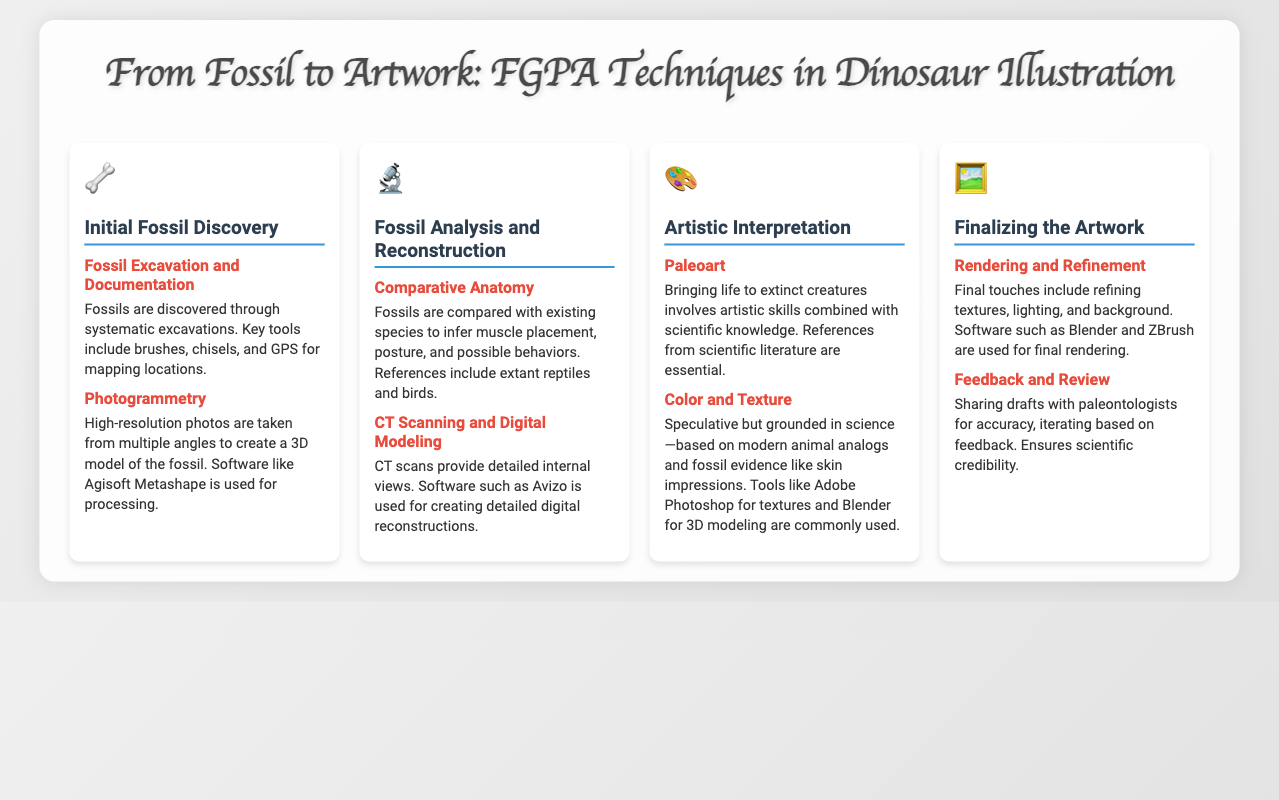What is used for mapping fossil locations? The document states that GPS is used for mapping locations of fossils during excavations.
Answer: GPS What software is used for photogrammetry? The document mentions Agisoft Metashape as the software used for processing high-resolution photos to create 3D models.
Answer: Agisoft Metashape What type of analysis helps infer muscle placement? The document indicates that comparative anatomy is used for inferring muscle placement, posture, and behaviors of fossils.
Answer: Comparative Anatomy Which scanning method provides detailed internal views? CT scanning is described in the document as providing detailed internal views of fossils.
Answer: CT scanning What tools are commonly used for color and texture in artwork? The document states that Adobe Photoshop and Blender are tools used for textures and 3D modeling in the artistic interpretation process.
Answer: Adobe Photoshop and Blender What is the final step before rendering artwork? The document explains that feedback and review involve sharing drafts with paleontologists for accuracy.
Answer: Feedback and Review How many steps are included in the FGPA techniques timeline? The document outlines four distinct steps in the FGPA techniques timeline from fossil discovery to artwork finalization.
Answer: Four Which creature types are primarily illustrated in this process? The artwork depicted primarily focuses on dinosaurs and other extinct creatures, as indicated in the title.
Answer: Dinosaurs and other extinct creatures 